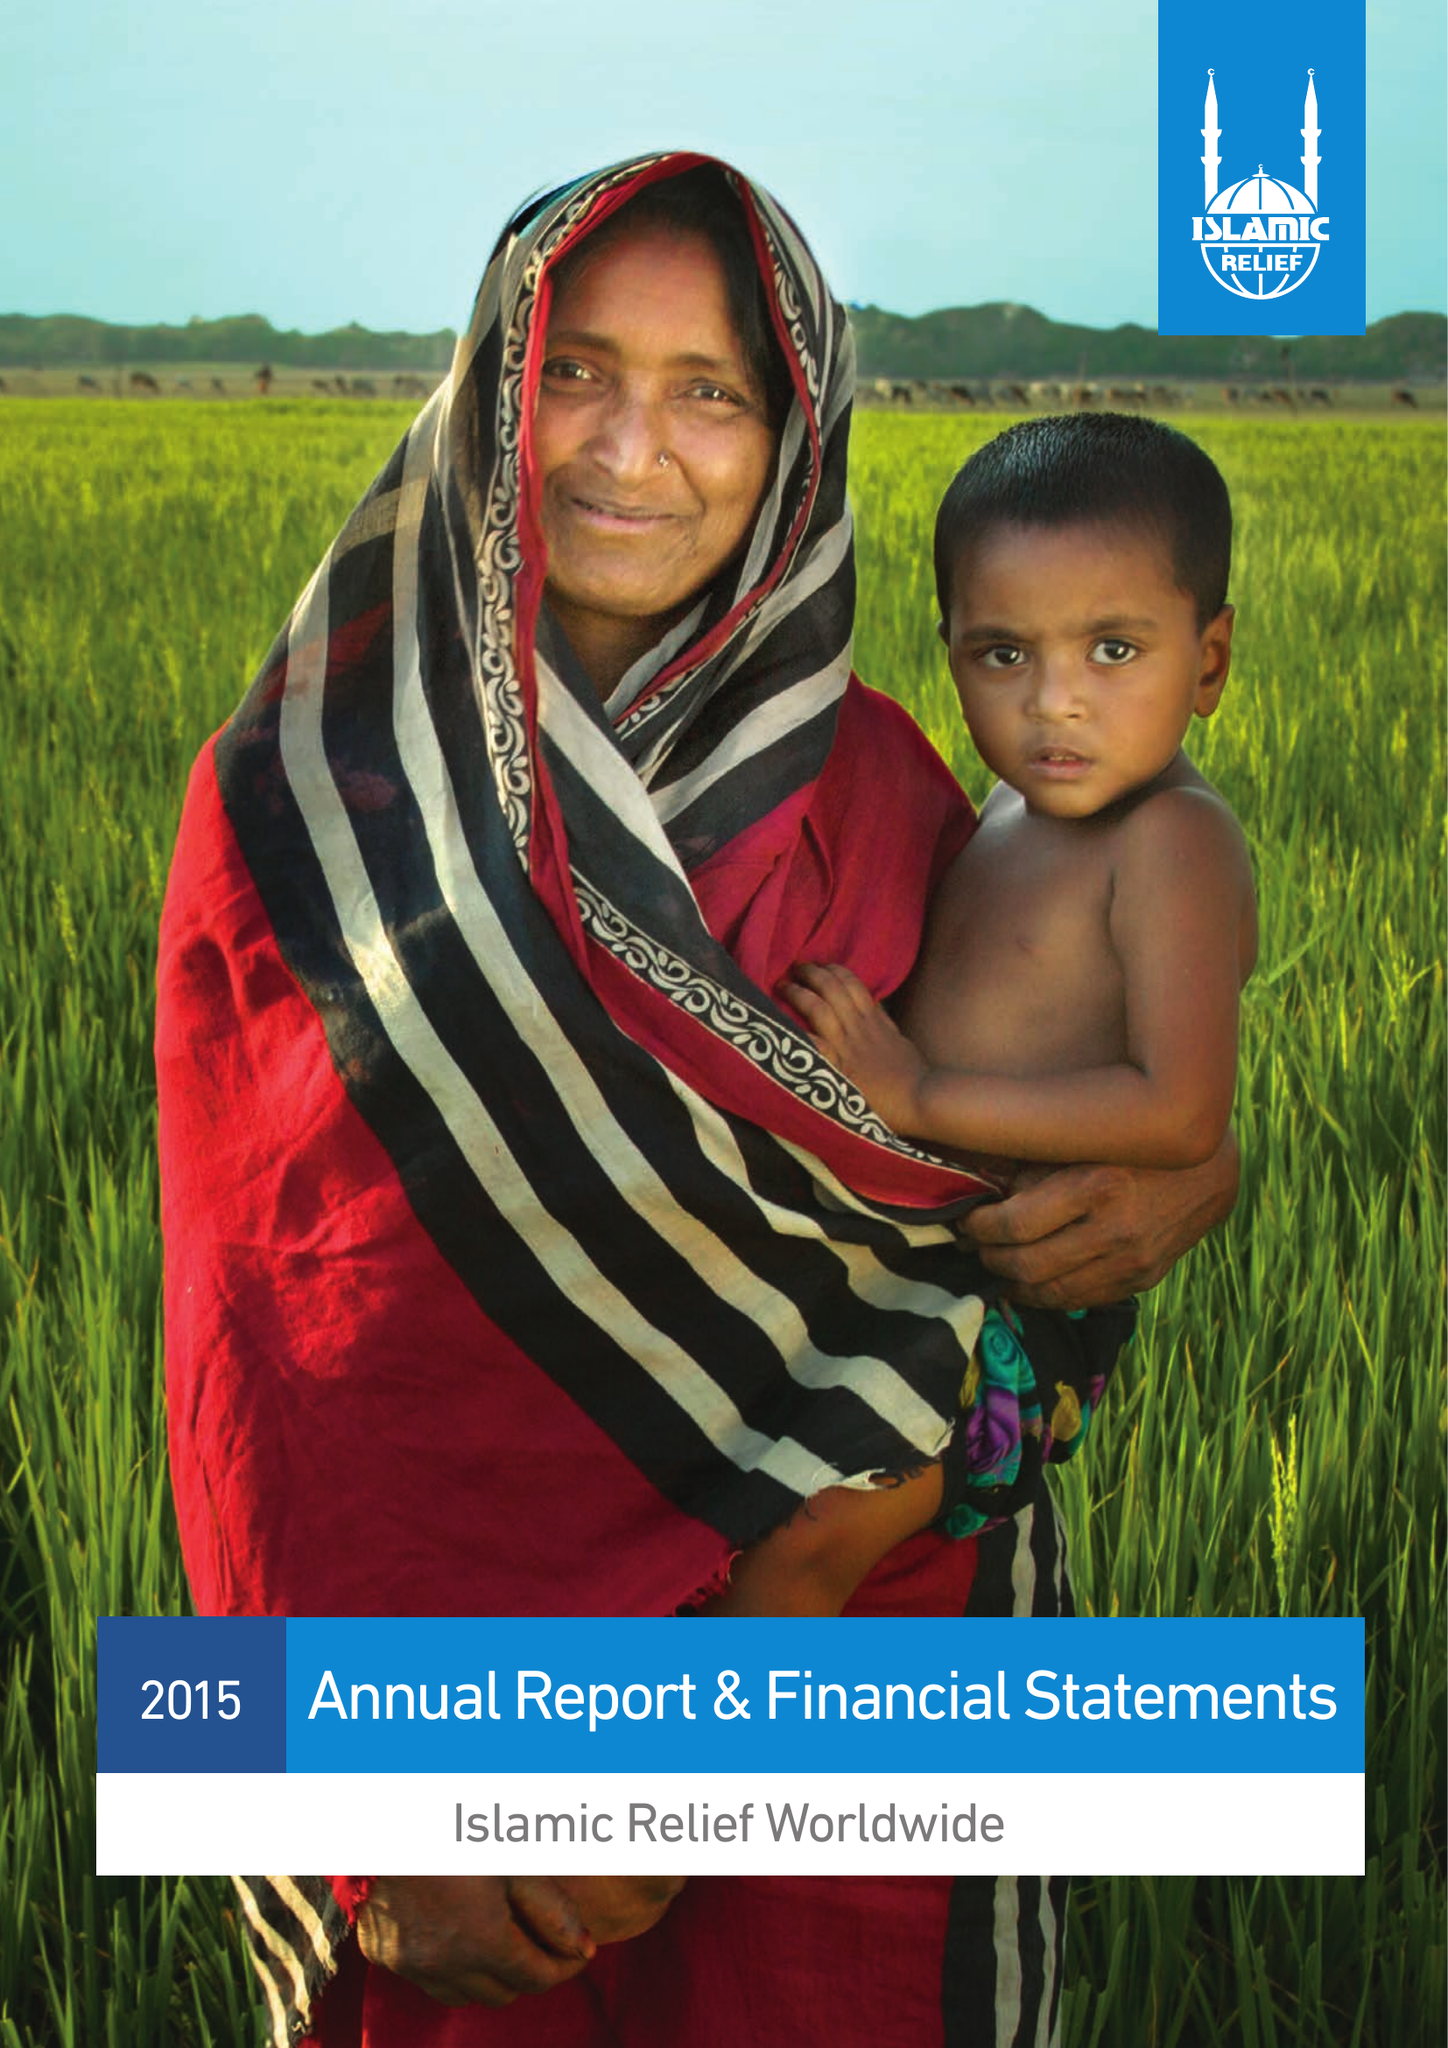What is the value for the report_date?
Answer the question using a single word or phrase. 2015-12-31 